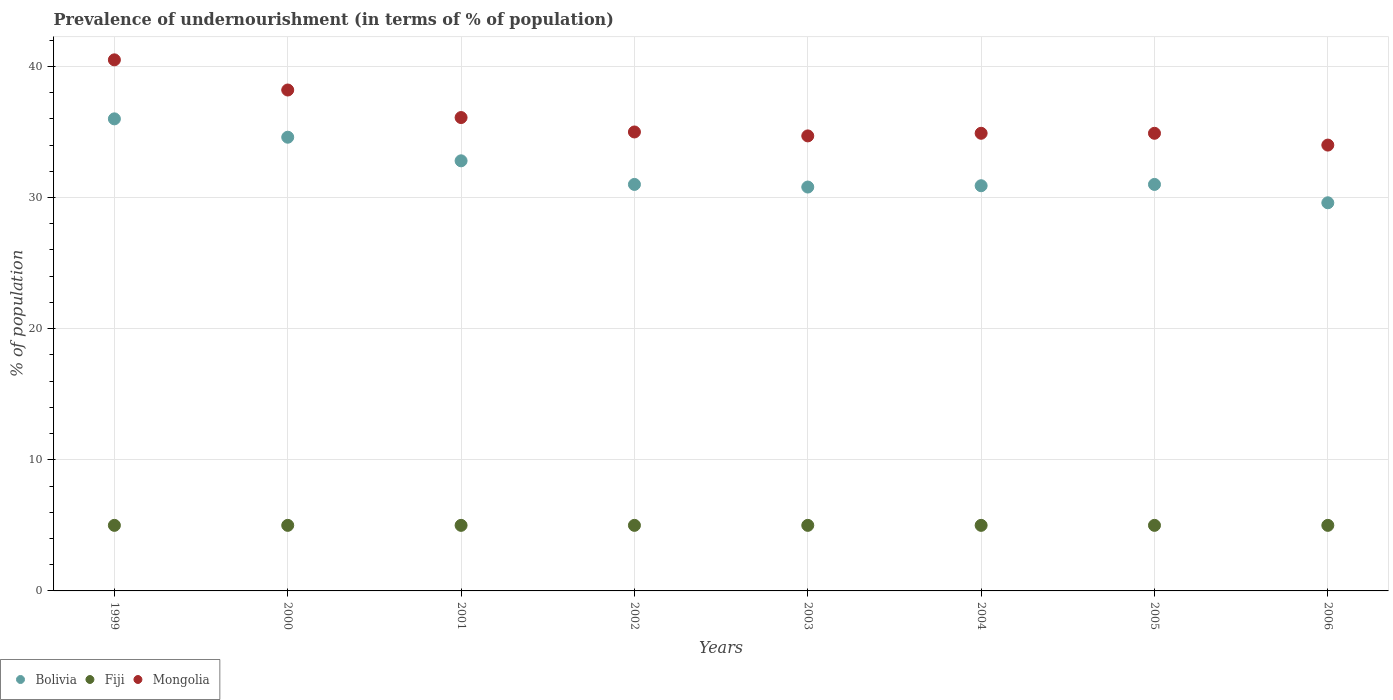How many different coloured dotlines are there?
Your response must be concise. 3. Is the number of dotlines equal to the number of legend labels?
Ensure brevity in your answer.  Yes. What is the percentage of undernourished population in Bolivia in 2002?
Offer a very short reply. 31. Across all years, what is the minimum percentage of undernourished population in Fiji?
Your answer should be compact. 5. What is the total percentage of undernourished population in Bolivia in the graph?
Give a very brief answer. 256.7. What is the difference between the percentage of undernourished population in Bolivia in 2004 and that in 2005?
Ensure brevity in your answer.  -0.1. What is the difference between the percentage of undernourished population in Fiji in 1999 and the percentage of undernourished population in Bolivia in 2005?
Offer a very short reply. -26. What is the average percentage of undernourished population in Bolivia per year?
Your answer should be compact. 32.09. In the year 2001, what is the difference between the percentage of undernourished population in Mongolia and percentage of undernourished population in Fiji?
Your answer should be very brief. 31.1. In how many years, is the percentage of undernourished population in Fiji greater than 16 %?
Ensure brevity in your answer.  0. What is the ratio of the percentage of undernourished population in Bolivia in 2001 to that in 2006?
Your answer should be compact. 1.11. What is the difference between the highest and the second highest percentage of undernourished population in Mongolia?
Offer a terse response. 2.3. What is the difference between the highest and the lowest percentage of undernourished population in Mongolia?
Give a very brief answer. 6.5. Is it the case that in every year, the sum of the percentage of undernourished population in Fiji and percentage of undernourished population in Mongolia  is greater than the percentage of undernourished population in Bolivia?
Make the answer very short. Yes. Does the percentage of undernourished population in Fiji monotonically increase over the years?
Keep it short and to the point. No. How many years are there in the graph?
Keep it short and to the point. 8. Are the values on the major ticks of Y-axis written in scientific E-notation?
Your answer should be very brief. No. Does the graph contain any zero values?
Give a very brief answer. No. Where does the legend appear in the graph?
Your answer should be very brief. Bottom left. How are the legend labels stacked?
Your answer should be compact. Horizontal. What is the title of the graph?
Offer a terse response. Prevalence of undernourishment (in terms of % of population). Does "Cambodia" appear as one of the legend labels in the graph?
Offer a terse response. No. What is the label or title of the Y-axis?
Your response must be concise. % of population. What is the % of population of Bolivia in 1999?
Keep it short and to the point. 36. What is the % of population in Fiji in 1999?
Provide a short and direct response. 5. What is the % of population in Mongolia in 1999?
Give a very brief answer. 40.5. What is the % of population in Bolivia in 2000?
Your response must be concise. 34.6. What is the % of population in Fiji in 2000?
Offer a terse response. 5. What is the % of population in Mongolia in 2000?
Make the answer very short. 38.2. What is the % of population of Bolivia in 2001?
Make the answer very short. 32.8. What is the % of population in Fiji in 2001?
Offer a very short reply. 5. What is the % of population of Mongolia in 2001?
Your response must be concise. 36.1. What is the % of population of Mongolia in 2002?
Provide a short and direct response. 35. What is the % of population in Bolivia in 2003?
Your response must be concise. 30.8. What is the % of population of Mongolia in 2003?
Ensure brevity in your answer.  34.7. What is the % of population of Bolivia in 2004?
Give a very brief answer. 30.9. What is the % of population in Mongolia in 2004?
Offer a very short reply. 34.9. What is the % of population of Bolivia in 2005?
Provide a short and direct response. 31. What is the % of population in Fiji in 2005?
Provide a succinct answer. 5. What is the % of population of Mongolia in 2005?
Ensure brevity in your answer.  34.9. What is the % of population in Bolivia in 2006?
Give a very brief answer. 29.6. What is the % of population in Mongolia in 2006?
Keep it short and to the point. 34. Across all years, what is the maximum % of population in Bolivia?
Make the answer very short. 36. Across all years, what is the maximum % of population in Mongolia?
Give a very brief answer. 40.5. Across all years, what is the minimum % of population of Bolivia?
Provide a succinct answer. 29.6. Across all years, what is the minimum % of population of Fiji?
Provide a succinct answer. 5. What is the total % of population in Bolivia in the graph?
Make the answer very short. 256.7. What is the total % of population of Fiji in the graph?
Your answer should be very brief. 40. What is the total % of population in Mongolia in the graph?
Give a very brief answer. 288.3. What is the difference between the % of population in Mongolia in 1999 and that in 2000?
Offer a very short reply. 2.3. What is the difference between the % of population in Bolivia in 1999 and that in 2001?
Offer a very short reply. 3.2. What is the difference between the % of population in Fiji in 1999 and that in 2001?
Ensure brevity in your answer.  0. What is the difference between the % of population of Mongolia in 1999 and that in 2001?
Your answer should be very brief. 4.4. What is the difference between the % of population in Fiji in 1999 and that in 2002?
Your response must be concise. 0. What is the difference between the % of population in Mongolia in 1999 and that in 2002?
Provide a succinct answer. 5.5. What is the difference between the % of population in Bolivia in 1999 and that in 2003?
Make the answer very short. 5.2. What is the difference between the % of population of Mongolia in 1999 and that in 2003?
Give a very brief answer. 5.8. What is the difference between the % of population of Fiji in 1999 and that in 2006?
Give a very brief answer. 0. What is the difference between the % of population in Fiji in 2000 and that in 2001?
Provide a short and direct response. 0. What is the difference between the % of population in Fiji in 2000 and that in 2002?
Your response must be concise. 0. What is the difference between the % of population of Fiji in 2000 and that in 2003?
Provide a succinct answer. 0. What is the difference between the % of population of Fiji in 2000 and that in 2004?
Make the answer very short. 0. What is the difference between the % of population in Mongolia in 2000 and that in 2004?
Provide a succinct answer. 3.3. What is the difference between the % of population in Fiji in 2000 and that in 2006?
Provide a succinct answer. 0. What is the difference between the % of population of Bolivia in 2001 and that in 2002?
Your answer should be very brief. 1.8. What is the difference between the % of population in Mongolia in 2001 and that in 2002?
Keep it short and to the point. 1.1. What is the difference between the % of population in Bolivia in 2001 and that in 2003?
Your answer should be compact. 2. What is the difference between the % of population in Fiji in 2001 and that in 2003?
Your answer should be compact. 0. What is the difference between the % of population in Bolivia in 2001 and that in 2004?
Provide a short and direct response. 1.9. What is the difference between the % of population of Mongolia in 2001 and that in 2004?
Make the answer very short. 1.2. What is the difference between the % of population in Bolivia in 2001 and that in 2005?
Give a very brief answer. 1.8. What is the difference between the % of population of Mongolia in 2001 and that in 2005?
Keep it short and to the point. 1.2. What is the difference between the % of population of Bolivia in 2002 and that in 2003?
Your answer should be compact. 0.2. What is the difference between the % of population of Mongolia in 2002 and that in 2004?
Provide a short and direct response. 0.1. What is the difference between the % of population of Bolivia in 2002 and that in 2006?
Provide a succinct answer. 1.4. What is the difference between the % of population of Fiji in 2002 and that in 2006?
Provide a succinct answer. 0. What is the difference between the % of population in Mongolia in 2003 and that in 2004?
Offer a terse response. -0.2. What is the difference between the % of population in Fiji in 2003 and that in 2005?
Your response must be concise. 0. What is the difference between the % of population in Mongolia in 2003 and that in 2005?
Ensure brevity in your answer.  -0.2. What is the difference between the % of population in Bolivia in 2003 and that in 2006?
Offer a very short reply. 1.2. What is the difference between the % of population in Fiji in 2003 and that in 2006?
Offer a terse response. 0. What is the difference between the % of population in Bolivia in 2004 and that in 2005?
Keep it short and to the point. -0.1. What is the difference between the % of population of Fiji in 2004 and that in 2006?
Your response must be concise. 0. What is the difference between the % of population in Mongolia in 2005 and that in 2006?
Make the answer very short. 0.9. What is the difference between the % of population of Bolivia in 1999 and the % of population of Fiji in 2000?
Offer a terse response. 31. What is the difference between the % of population in Bolivia in 1999 and the % of population in Mongolia in 2000?
Offer a very short reply. -2.2. What is the difference between the % of population of Fiji in 1999 and the % of population of Mongolia in 2000?
Your answer should be compact. -33.2. What is the difference between the % of population in Bolivia in 1999 and the % of population in Fiji in 2001?
Give a very brief answer. 31. What is the difference between the % of population in Bolivia in 1999 and the % of population in Mongolia in 2001?
Your answer should be very brief. -0.1. What is the difference between the % of population in Fiji in 1999 and the % of population in Mongolia in 2001?
Your answer should be very brief. -31.1. What is the difference between the % of population of Bolivia in 1999 and the % of population of Mongolia in 2002?
Provide a short and direct response. 1. What is the difference between the % of population in Fiji in 1999 and the % of population in Mongolia in 2002?
Ensure brevity in your answer.  -30. What is the difference between the % of population in Fiji in 1999 and the % of population in Mongolia in 2003?
Give a very brief answer. -29.7. What is the difference between the % of population of Fiji in 1999 and the % of population of Mongolia in 2004?
Offer a terse response. -29.9. What is the difference between the % of population in Bolivia in 1999 and the % of population in Fiji in 2005?
Ensure brevity in your answer.  31. What is the difference between the % of population of Bolivia in 1999 and the % of population of Mongolia in 2005?
Provide a short and direct response. 1.1. What is the difference between the % of population in Fiji in 1999 and the % of population in Mongolia in 2005?
Offer a very short reply. -29.9. What is the difference between the % of population in Bolivia in 1999 and the % of population in Mongolia in 2006?
Provide a succinct answer. 2. What is the difference between the % of population of Bolivia in 2000 and the % of population of Fiji in 2001?
Give a very brief answer. 29.6. What is the difference between the % of population of Fiji in 2000 and the % of population of Mongolia in 2001?
Offer a very short reply. -31.1. What is the difference between the % of population of Bolivia in 2000 and the % of population of Fiji in 2002?
Give a very brief answer. 29.6. What is the difference between the % of population in Bolivia in 2000 and the % of population in Mongolia in 2002?
Ensure brevity in your answer.  -0.4. What is the difference between the % of population of Fiji in 2000 and the % of population of Mongolia in 2002?
Provide a short and direct response. -30. What is the difference between the % of population of Bolivia in 2000 and the % of population of Fiji in 2003?
Offer a terse response. 29.6. What is the difference between the % of population of Bolivia in 2000 and the % of population of Mongolia in 2003?
Keep it short and to the point. -0.1. What is the difference between the % of population of Fiji in 2000 and the % of population of Mongolia in 2003?
Provide a succinct answer. -29.7. What is the difference between the % of population in Bolivia in 2000 and the % of population in Fiji in 2004?
Your answer should be compact. 29.6. What is the difference between the % of population of Fiji in 2000 and the % of population of Mongolia in 2004?
Offer a terse response. -29.9. What is the difference between the % of population of Bolivia in 2000 and the % of population of Fiji in 2005?
Offer a terse response. 29.6. What is the difference between the % of population in Fiji in 2000 and the % of population in Mongolia in 2005?
Provide a succinct answer. -29.9. What is the difference between the % of population in Bolivia in 2000 and the % of population in Fiji in 2006?
Your answer should be compact. 29.6. What is the difference between the % of population of Bolivia in 2000 and the % of population of Mongolia in 2006?
Your response must be concise. 0.6. What is the difference between the % of population in Bolivia in 2001 and the % of population in Fiji in 2002?
Your answer should be very brief. 27.8. What is the difference between the % of population of Bolivia in 2001 and the % of population of Mongolia in 2002?
Offer a very short reply. -2.2. What is the difference between the % of population in Fiji in 2001 and the % of population in Mongolia in 2002?
Your answer should be very brief. -30. What is the difference between the % of population in Bolivia in 2001 and the % of population in Fiji in 2003?
Provide a succinct answer. 27.8. What is the difference between the % of population of Fiji in 2001 and the % of population of Mongolia in 2003?
Your answer should be compact. -29.7. What is the difference between the % of population of Bolivia in 2001 and the % of population of Fiji in 2004?
Offer a terse response. 27.8. What is the difference between the % of population of Bolivia in 2001 and the % of population of Mongolia in 2004?
Your response must be concise. -2.1. What is the difference between the % of population in Fiji in 2001 and the % of population in Mongolia in 2004?
Offer a terse response. -29.9. What is the difference between the % of population of Bolivia in 2001 and the % of population of Fiji in 2005?
Your response must be concise. 27.8. What is the difference between the % of population in Fiji in 2001 and the % of population in Mongolia in 2005?
Your answer should be compact. -29.9. What is the difference between the % of population in Bolivia in 2001 and the % of population in Fiji in 2006?
Provide a short and direct response. 27.8. What is the difference between the % of population in Bolivia in 2002 and the % of population in Fiji in 2003?
Offer a very short reply. 26. What is the difference between the % of population in Bolivia in 2002 and the % of population in Mongolia in 2003?
Offer a terse response. -3.7. What is the difference between the % of population in Fiji in 2002 and the % of population in Mongolia in 2003?
Offer a terse response. -29.7. What is the difference between the % of population of Bolivia in 2002 and the % of population of Fiji in 2004?
Your response must be concise. 26. What is the difference between the % of population of Bolivia in 2002 and the % of population of Mongolia in 2004?
Provide a succinct answer. -3.9. What is the difference between the % of population of Fiji in 2002 and the % of population of Mongolia in 2004?
Your answer should be compact. -29.9. What is the difference between the % of population in Bolivia in 2002 and the % of population in Fiji in 2005?
Offer a very short reply. 26. What is the difference between the % of population in Bolivia in 2002 and the % of population in Mongolia in 2005?
Give a very brief answer. -3.9. What is the difference between the % of population in Fiji in 2002 and the % of population in Mongolia in 2005?
Give a very brief answer. -29.9. What is the difference between the % of population in Bolivia in 2002 and the % of population in Fiji in 2006?
Keep it short and to the point. 26. What is the difference between the % of population in Fiji in 2002 and the % of population in Mongolia in 2006?
Keep it short and to the point. -29. What is the difference between the % of population in Bolivia in 2003 and the % of population in Fiji in 2004?
Make the answer very short. 25.8. What is the difference between the % of population in Fiji in 2003 and the % of population in Mongolia in 2004?
Your response must be concise. -29.9. What is the difference between the % of population of Bolivia in 2003 and the % of population of Fiji in 2005?
Your answer should be very brief. 25.8. What is the difference between the % of population of Fiji in 2003 and the % of population of Mongolia in 2005?
Make the answer very short. -29.9. What is the difference between the % of population in Bolivia in 2003 and the % of population in Fiji in 2006?
Keep it short and to the point. 25.8. What is the difference between the % of population in Bolivia in 2003 and the % of population in Mongolia in 2006?
Your response must be concise. -3.2. What is the difference between the % of population in Fiji in 2003 and the % of population in Mongolia in 2006?
Keep it short and to the point. -29. What is the difference between the % of population of Bolivia in 2004 and the % of population of Fiji in 2005?
Give a very brief answer. 25.9. What is the difference between the % of population in Fiji in 2004 and the % of population in Mongolia in 2005?
Provide a short and direct response. -29.9. What is the difference between the % of population in Bolivia in 2004 and the % of population in Fiji in 2006?
Provide a short and direct response. 25.9. What is the difference between the % of population of Bolivia in 2004 and the % of population of Mongolia in 2006?
Your answer should be very brief. -3.1. What is the difference between the % of population of Bolivia in 2005 and the % of population of Fiji in 2006?
Provide a short and direct response. 26. What is the difference between the % of population in Bolivia in 2005 and the % of population in Mongolia in 2006?
Provide a succinct answer. -3. What is the average % of population in Bolivia per year?
Offer a terse response. 32.09. What is the average % of population in Mongolia per year?
Make the answer very short. 36.04. In the year 1999, what is the difference between the % of population of Bolivia and % of population of Fiji?
Your response must be concise. 31. In the year 1999, what is the difference between the % of population of Bolivia and % of population of Mongolia?
Offer a terse response. -4.5. In the year 1999, what is the difference between the % of population of Fiji and % of population of Mongolia?
Your answer should be very brief. -35.5. In the year 2000, what is the difference between the % of population of Bolivia and % of population of Fiji?
Offer a very short reply. 29.6. In the year 2000, what is the difference between the % of population of Bolivia and % of population of Mongolia?
Provide a succinct answer. -3.6. In the year 2000, what is the difference between the % of population of Fiji and % of population of Mongolia?
Your response must be concise. -33.2. In the year 2001, what is the difference between the % of population of Bolivia and % of population of Fiji?
Your response must be concise. 27.8. In the year 2001, what is the difference between the % of population in Fiji and % of population in Mongolia?
Offer a terse response. -31.1. In the year 2002, what is the difference between the % of population of Bolivia and % of population of Fiji?
Your response must be concise. 26. In the year 2002, what is the difference between the % of population of Bolivia and % of population of Mongolia?
Provide a succinct answer. -4. In the year 2003, what is the difference between the % of population of Bolivia and % of population of Fiji?
Offer a very short reply. 25.8. In the year 2003, what is the difference between the % of population in Bolivia and % of population in Mongolia?
Your answer should be very brief. -3.9. In the year 2003, what is the difference between the % of population in Fiji and % of population in Mongolia?
Make the answer very short. -29.7. In the year 2004, what is the difference between the % of population of Bolivia and % of population of Fiji?
Your answer should be very brief. 25.9. In the year 2004, what is the difference between the % of population of Fiji and % of population of Mongolia?
Provide a succinct answer. -29.9. In the year 2005, what is the difference between the % of population in Bolivia and % of population in Fiji?
Offer a terse response. 26. In the year 2005, what is the difference between the % of population of Bolivia and % of population of Mongolia?
Keep it short and to the point. -3.9. In the year 2005, what is the difference between the % of population of Fiji and % of population of Mongolia?
Make the answer very short. -29.9. In the year 2006, what is the difference between the % of population in Bolivia and % of population in Fiji?
Your answer should be very brief. 24.6. In the year 2006, what is the difference between the % of population of Fiji and % of population of Mongolia?
Offer a very short reply. -29. What is the ratio of the % of population of Bolivia in 1999 to that in 2000?
Your answer should be compact. 1.04. What is the ratio of the % of population in Fiji in 1999 to that in 2000?
Ensure brevity in your answer.  1. What is the ratio of the % of population in Mongolia in 1999 to that in 2000?
Your answer should be very brief. 1.06. What is the ratio of the % of population of Bolivia in 1999 to that in 2001?
Make the answer very short. 1.1. What is the ratio of the % of population in Fiji in 1999 to that in 2001?
Your answer should be compact. 1. What is the ratio of the % of population of Mongolia in 1999 to that in 2001?
Your response must be concise. 1.12. What is the ratio of the % of population of Bolivia in 1999 to that in 2002?
Your answer should be very brief. 1.16. What is the ratio of the % of population in Mongolia in 1999 to that in 2002?
Keep it short and to the point. 1.16. What is the ratio of the % of population of Bolivia in 1999 to that in 2003?
Make the answer very short. 1.17. What is the ratio of the % of population in Fiji in 1999 to that in 2003?
Make the answer very short. 1. What is the ratio of the % of population in Mongolia in 1999 to that in 2003?
Provide a short and direct response. 1.17. What is the ratio of the % of population in Bolivia in 1999 to that in 2004?
Offer a very short reply. 1.17. What is the ratio of the % of population of Mongolia in 1999 to that in 2004?
Give a very brief answer. 1.16. What is the ratio of the % of population of Bolivia in 1999 to that in 2005?
Your response must be concise. 1.16. What is the ratio of the % of population in Fiji in 1999 to that in 2005?
Your answer should be very brief. 1. What is the ratio of the % of population of Mongolia in 1999 to that in 2005?
Offer a very short reply. 1.16. What is the ratio of the % of population of Bolivia in 1999 to that in 2006?
Ensure brevity in your answer.  1.22. What is the ratio of the % of population of Fiji in 1999 to that in 2006?
Give a very brief answer. 1. What is the ratio of the % of population of Mongolia in 1999 to that in 2006?
Give a very brief answer. 1.19. What is the ratio of the % of population in Bolivia in 2000 to that in 2001?
Your answer should be very brief. 1.05. What is the ratio of the % of population of Fiji in 2000 to that in 2001?
Offer a terse response. 1. What is the ratio of the % of population in Mongolia in 2000 to that in 2001?
Make the answer very short. 1.06. What is the ratio of the % of population of Bolivia in 2000 to that in 2002?
Offer a terse response. 1.12. What is the ratio of the % of population of Mongolia in 2000 to that in 2002?
Offer a very short reply. 1.09. What is the ratio of the % of population in Bolivia in 2000 to that in 2003?
Make the answer very short. 1.12. What is the ratio of the % of population in Mongolia in 2000 to that in 2003?
Ensure brevity in your answer.  1.1. What is the ratio of the % of population in Bolivia in 2000 to that in 2004?
Keep it short and to the point. 1.12. What is the ratio of the % of population of Fiji in 2000 to that in 2004?
Your response must be concise. 1. What is the ratio of the % of population in Mongolia in 2000 to that in 2004?
Offer a very short reply. 1.09. What is the ratio of the % of population of Bolivia in 2000 to that in 2005?
Provide a succinct answer. 1.12. What is the ratio of the % of population of Fiji in 2000 to that in 2005?
Keep it short and to the point. 1. What is the ratio of the % of population in Mongolia in 2000 to that in 2005?
Your response must be concise. 1.09. What is the ratio of the % of population of Bolivia in 2000 to that in 2006?
Make the answer very short. 1.17. What is the ratio of the % of population in Fiji in 2000 to that in 2006?
Provide a succinct answer. 1. What is the ratio of the % of population of Mongolia in 2000 to that in 2006?
Your answer should be very brief. 1.12. What is the ratio of the % of population of Bolivia in 2001 to that in 2002?
Keep it short and to the point. 1.06. What is the ratio of the % of population of Mongolia in 2001 to that in 2002?
Keep it short and to the point. 1.03. What is the ratio of the % of population of Bolivia in 2001 to that in 2003?
Offer a terse response. 1.06. What is the ratio of the % of population in Mongolia in 2001 to that in 2003?
Provide a succinct answer. 1.04. What is the ratio of the % of population in Bolivia in 2001 to that in 2004?
Offer a very short reply. 1.06. What is the ratio of the % of population of Fiji in 2001 to that in 2004?
Your response must be concise. 1. What is the ratio of the % of population of Mongolia in 2001 to that in 2004?
Offer a very short reply. 1.03. What is the ratio of the % of population in Bolivia in 2001 to that in 2005?
Ensure brevity in your answer.  1.06. What is the ratio of the % of population of Mongolia in 2001 to that in 2005?
Offer a very short reply. 1.03. What is the ratio of the % of population in Bolivia in 2001 to that in 2006?
Offer a terse response. 1.11. What is the ratio of the % of population of Fiji in 2001 to that in 2006?
Provide a short and direct response. 1. What is the ratio of the % of population in Mongolia in 2001 to that in 2006?
Your response must be concise. 1.06. What is the ratio of the % of population in Bolivia in 2002 to that in 2003?
Your answer should be very brief. 1.01. What is the ratio of the % of population in Fiji in 2002 to that in 2003?
Offer a very short reply. 1. What is the ratio of the % of population in Mongolia in 2002 to that in 2003?
Provide a succinct answer. 1.01. What is the ratio of the % of population of Bolivia in 2002 to that in 2004?
Provide a short and direct response. 1. What is the ratio of the % of population in Mongolia in 2002 to that in 2005?
Offer a terse response. 1. What is the ratio of the % of population of Bolivia in 2002 to that in 2006?
Your answer should be very brief. 1.05. What is the ratio of the % of population in Mongolia in 2002 to that in 2006?
Make the answer very short. 1.03. What is the ratio of the % of population in Bolivia in 2003 to that in 2004?
Provide a short and direct response. 1. What is the ratio of the % of population of Fiji in 2003 to that in 2004?
Provide a short and direct response. 1. What is the ratio of the % of population of Mongolia in 2003 to that in 2004?
Give a very brief answer. 0.99. What is the ratio of the % of population of Fiji in 2003 to that in 2005?
Provide a succinct answer. 1. What is the ratio of the % of population of Mongolia in 2003 to that in 2005?
Provide a short and direct response. 0.99. What is the ratio of the % of population of Bolivia in 2003 to that in 2006?
Offer a very short reply. 1.04. What is the ratio of the % of population in Fiji in 2003 to that in 2006?
Your answer should be very brief. 1. What is the ratio of the % of population of Mongolia in 2003 to that in 2006?
Your answer should be compact. 1.02. What is the ratio of the % of population of Bolivia in 2004 to that in 2005?
Ensure brevity in your answer.  1. What is the ratio of the % of population of Fiji in 2004 to that in 2005?
Your response must be concise. 1. What is the ratio of the % of population in Mongolia in 2004 to that in 2005?
Your answer should be compact. 1. What is the ratio of the % of population of Bolivia in 2004 to that in 2006?
Keep it short and to the point. 1.04. What is the ratio of the % of population in Fiji in 2004 to that in 2006?
Keep it short and to the point. 1. What is the ratio of the % of population of Mongolia in 2004 to that in 2006?
Ensure brevity in your answer.  1.03. What is the ratio of the % of population in Bolivia in 2005 to that in 2006?
Provide a short and direct response. 1.05. What is the ratio of the % of population in Fiji in 2005 to that in 2006?
Offer a terse response. 1. What is the ratio of the % of population in Mongolia in 2005 to that in 2006?
Ensure brevity in your answer.  1.03. What is the difference between the highest and the lowest % of population of Fiji?
Your response must be concise. 0. What is the difference between the highest and the lowest % of population in Mongolia?
Keep it short and to the point. 6.5. 